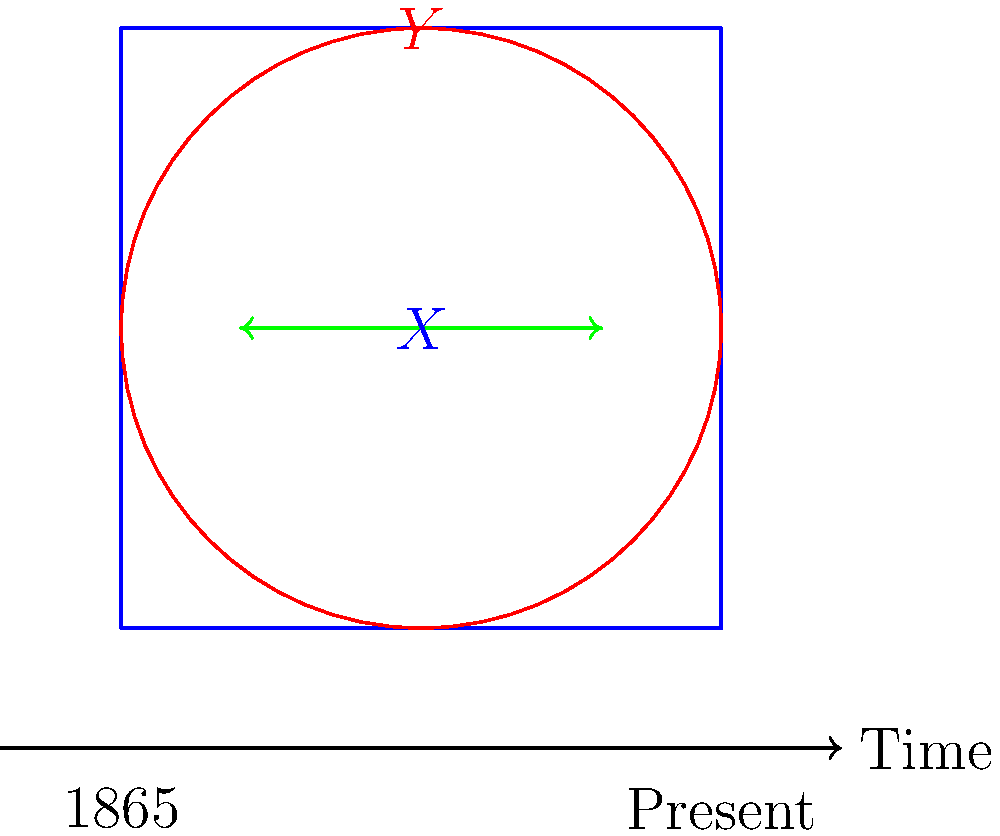Consider the topological spaces $X$ (blue square) and $Y$ (red circle) representing the evolution of voting rights from 1865 to the present. Are these spaces homotopy equivalent? If so, explain how this relates to the progression of voting rights for African Americans. To determine if the spaces $X$ and $Y$ are homotopy equivalent, we need to consider the following steps:

1. Definition: Two topological spaces are homotopy equivalent if there exist continuous maps $f: X \rightarrow Y$ and $g: Y \rightarrow X$ such that their compositions $g \circ f$ and $f \circ g$ are homotopic to the identity maps on $X$ and $Y$, respectively.

2. In this case, $X$ (blue square) and $Y$ (red circle) are indeed homotopy equivalent. Both spaces are contractible, meaning they can be continuously deformed to a single point.

3. We can define:
   $f: X \rightarrow Y$ as a map that contracts the square to its center point, then expands it to fill the circle.
   $g: Y \rightarrow X$ as a map that contracts the circle to its center point, then expands it to fill the square.

4. Both $g \circ f$ and $f \circ g$ can be continuously deformed to the identity maps on their respective spaces.

5. Relating to voting rights:
   - The square $X$ represents the state of voting rights in 1865 (post-Civil War).
   - The circle $Y$ represents the current state of voting rights.
   - The homotopy equivalence suggests that while the "shape" of voting rights has changed, the fundamental structure remains similar.

6. This equivalence reflects the journey of African American voting rights:
   - Initial progress with the 15th Amendment (1870)
   - Setbacks during Jim Crow era
   - Advancements with the Civil Rights Movement and Voting Rights Act (1965)
   - Ongoing challenges and progress in ensuring equal voting access

7. The continuous deformation between the spaces represents the gradual nature of civil rights progress, with both advancements and setbacks, but an overall preservation of the fundamental right to vote.
Answer: Yes, homotopy equivalent. Represents continuous evolution of voting rights despite changes in form. 